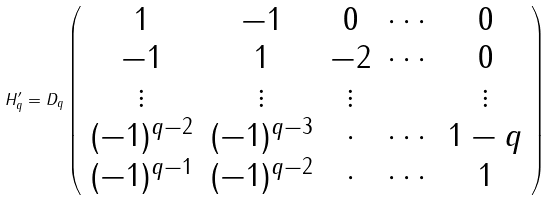Convert formula to latex. <formula><loc_0><loc_0><loc_500><loc_500>H ^ { \prime } _ { q } = D _ { q } \left ( \begin{array} { c c c c c } 1 & - 1 & 0 & \cdots & 0 \\ - 1 & 1 & - 2 & \cdots & 0 \\ \vdots & \vdots & \vdots & & \vdots \\ ( - 1 ) ^ { q - 2 } & ( - 1 ) ^ { q - 3 } & \cdot & \cdots & 1 - q \\ ( - 1 ) ^ { q - 1 } & ( - 1 ) ^ { q - 2 } & \cdot & \cdots & 1 \end{array} \right )</formula> 